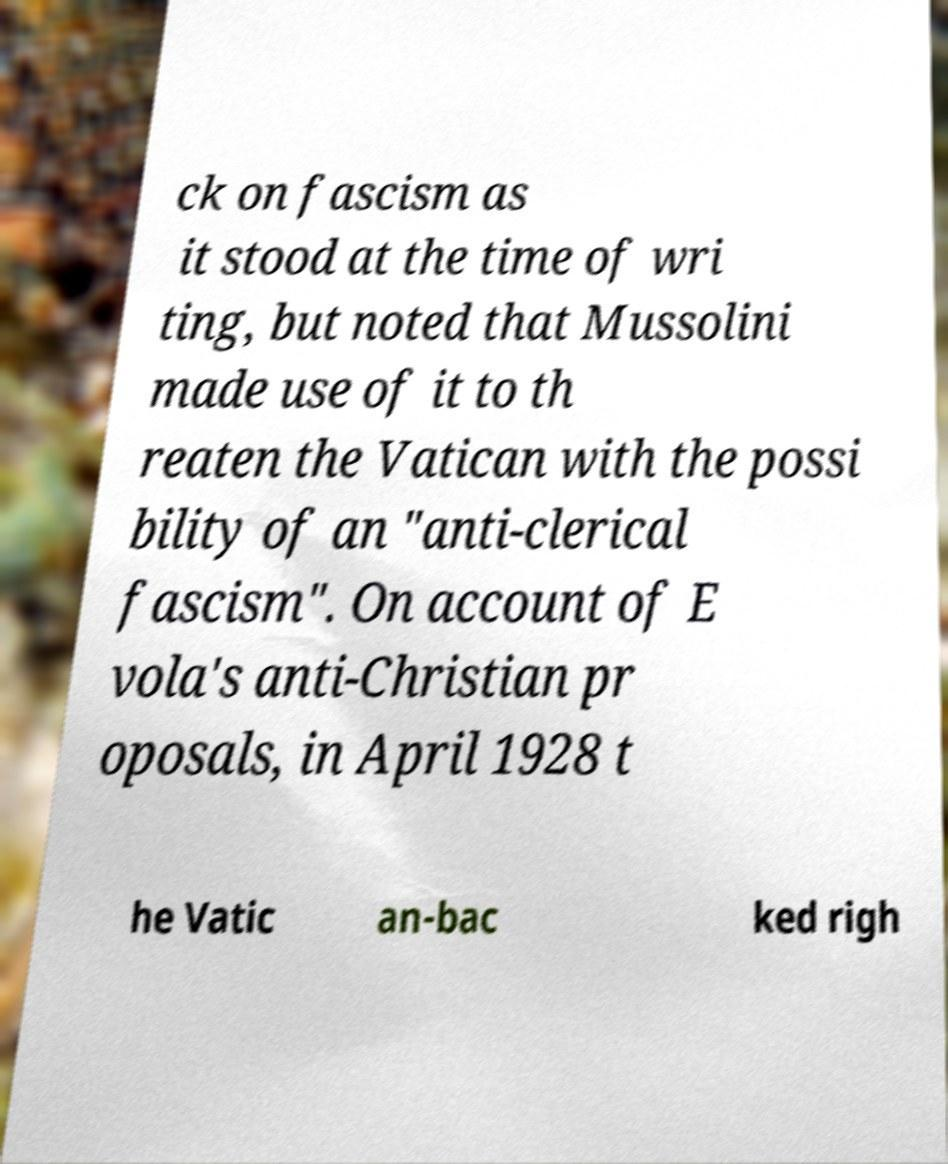What messages or text are displayed in this image? I need them in a readable, typed format. ck on fascism as it stood at the time of wri ting, but noted that Mussolini made use of it to th reaten the Vatican with the possi bility of an "anti-clerical fascism". On account of E vola's anti-Christian pr oposals, in April 1928 t he Vatic an-bac ked righ 